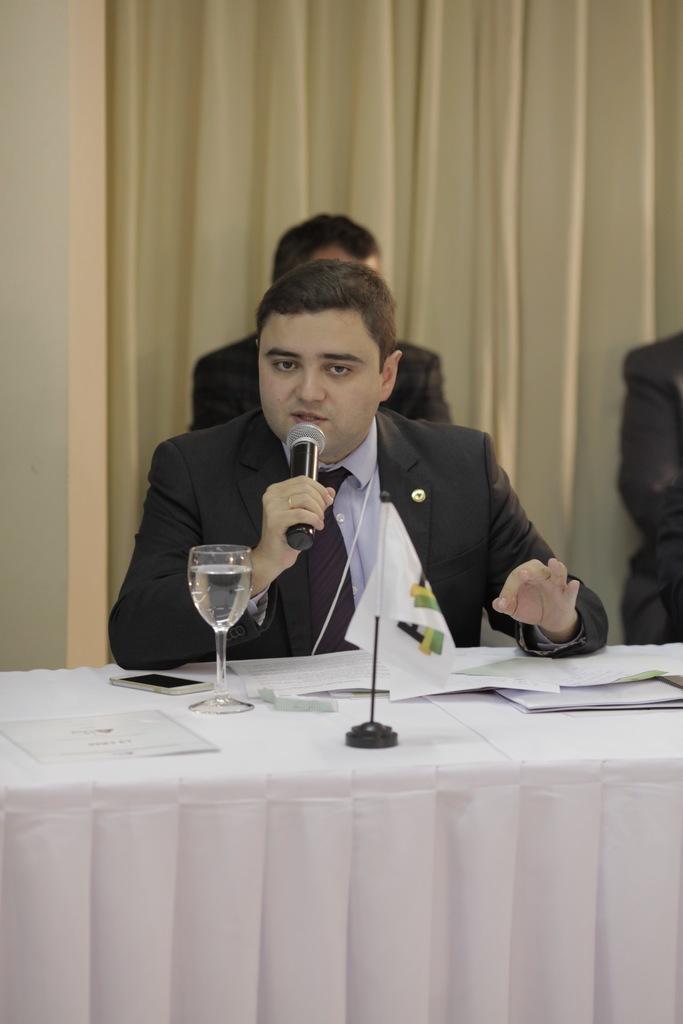Describe this image in one or two sentences. A man is speaking with a mic in his hand sitting at a table. 